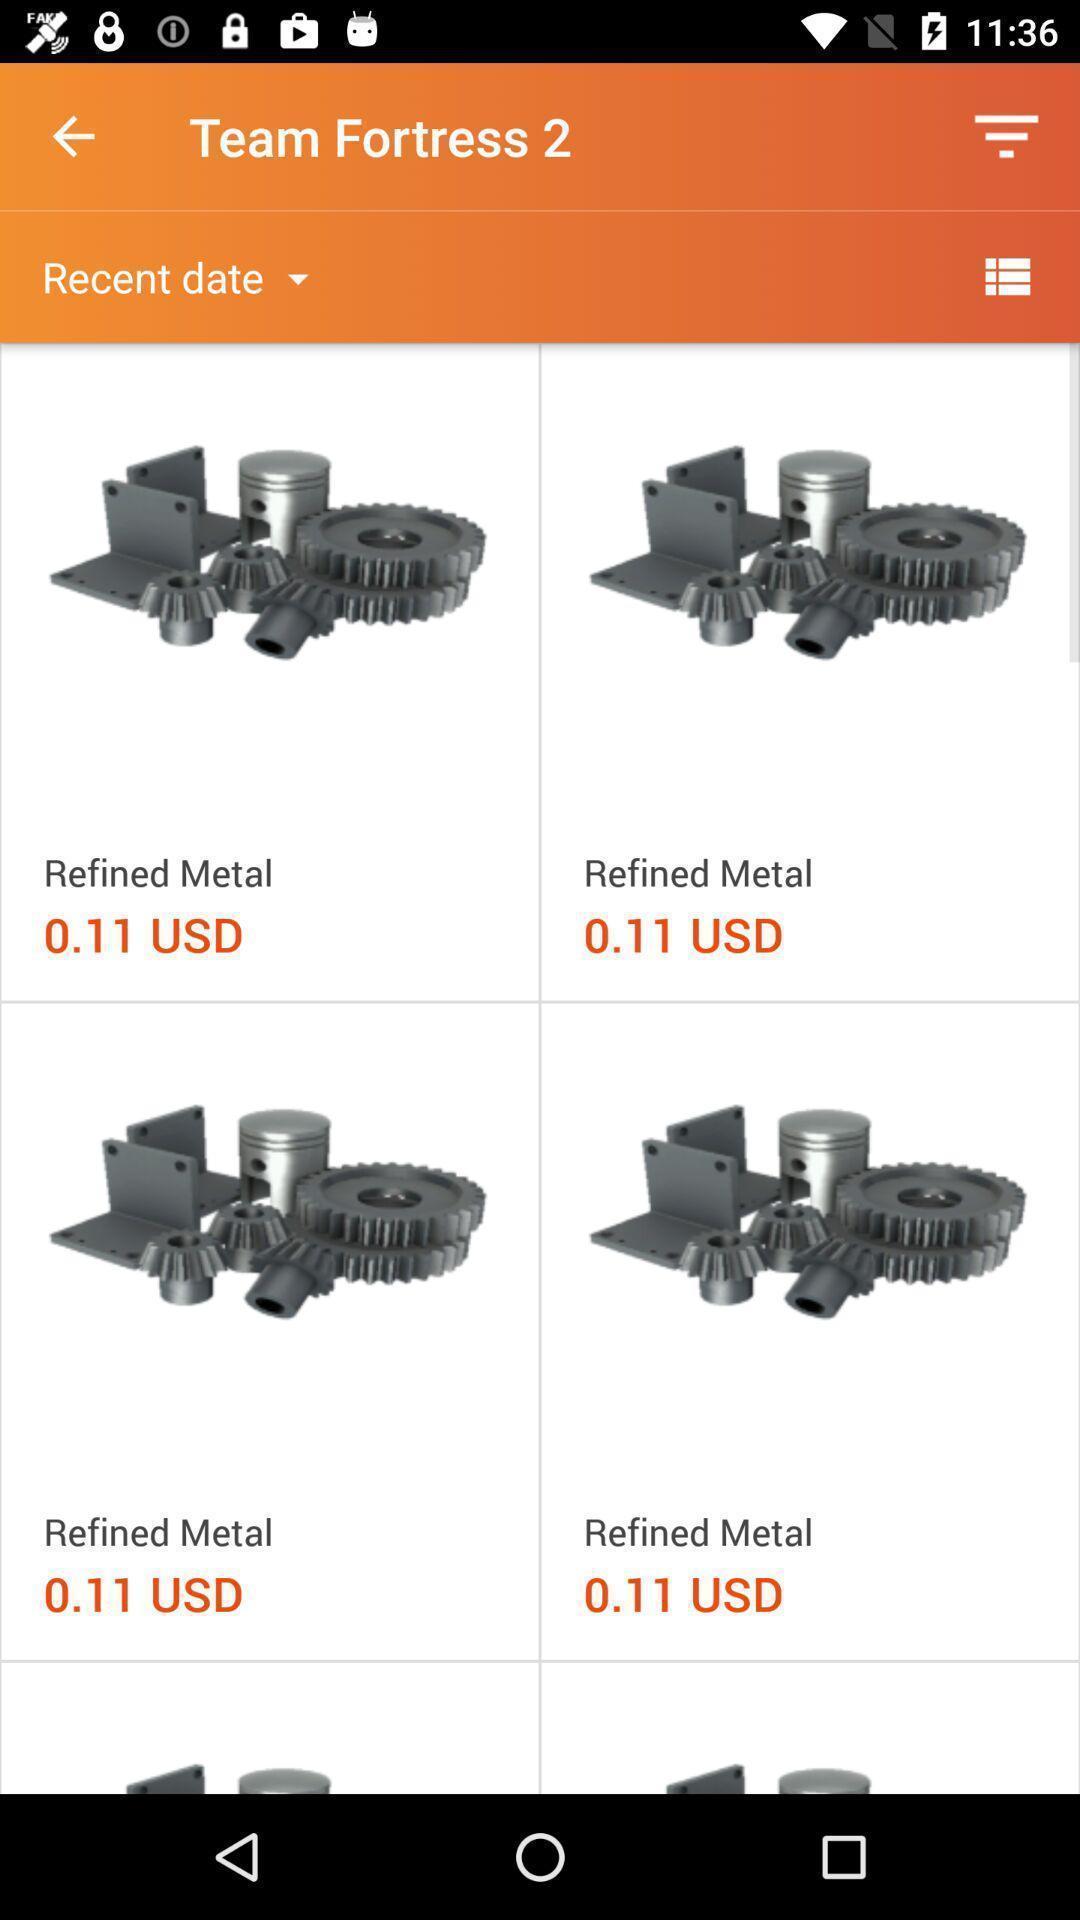Describe the visual elements of this screenshot. Page of a game shopping application. 